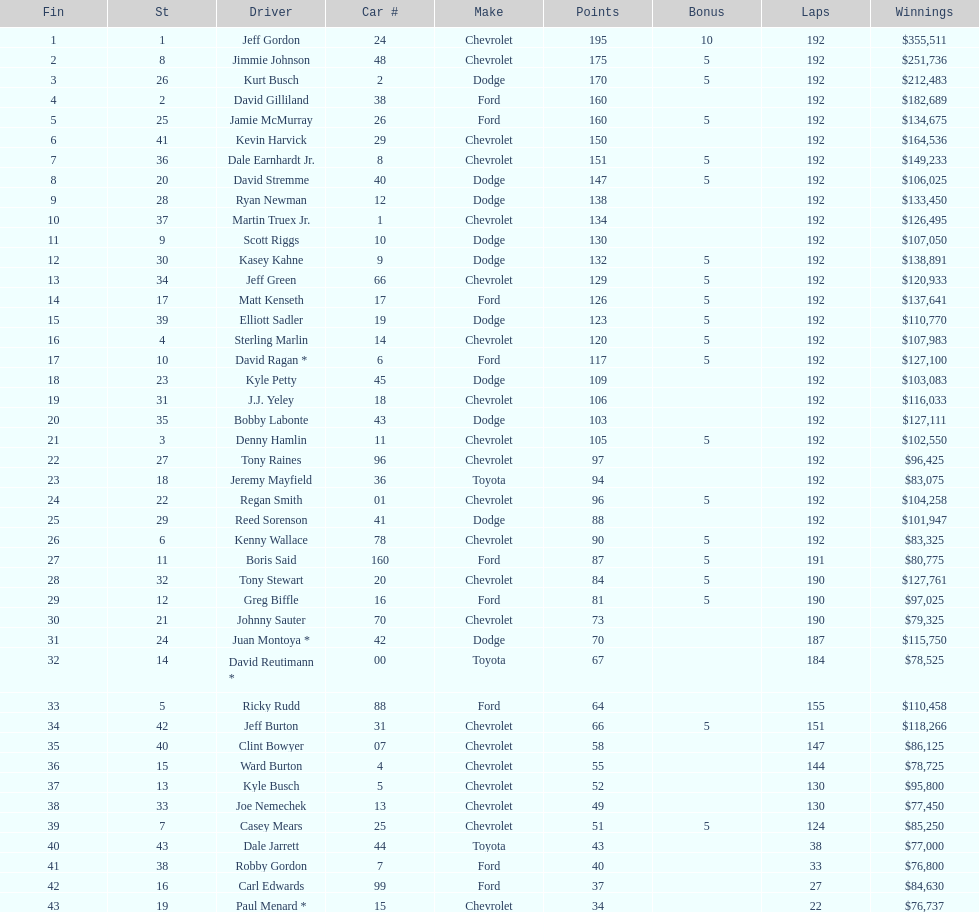Which individual has the highest number of wins on this list? Jeff Gordon. 